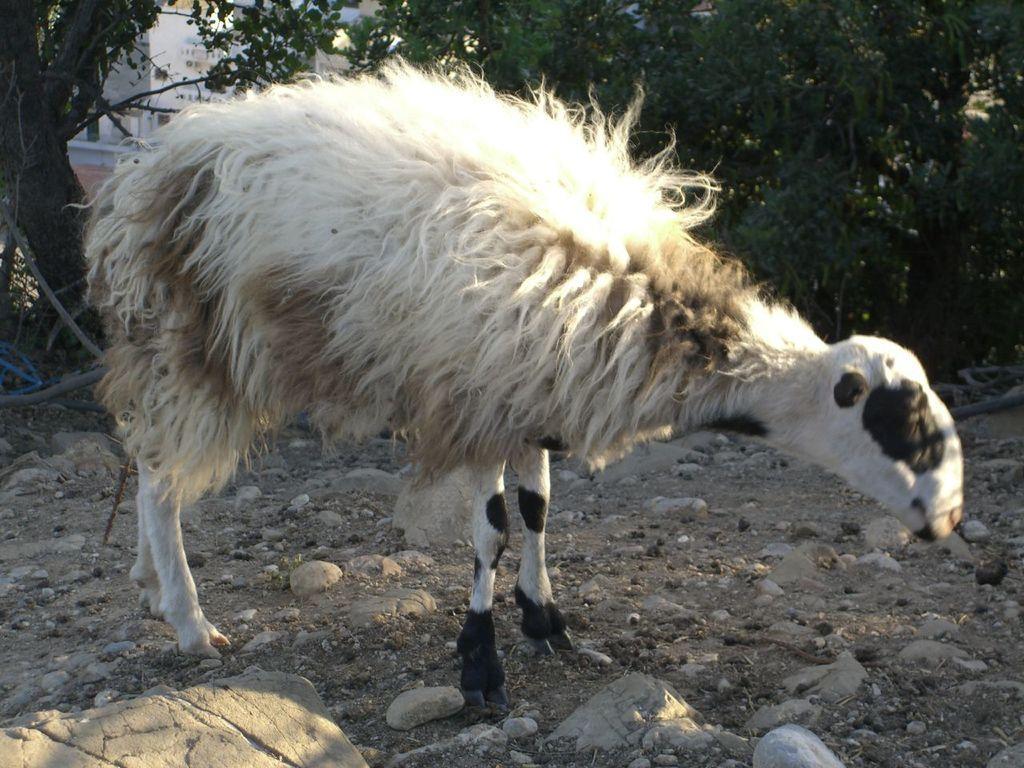Please provide a concise description of this image. In the foreground of this image, there is a sheep on the land where we can see few stones. In the background, there are trees and it seems like a building. 